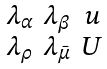Convert formula to latex. <formula><loc_0><loc_0><loc_500><loc_500>\begin{smallmatrix} \lambda _ { \alpha } & \lambda _ { \beta } & u \\ \lambda _ { \rho } & \lambda _ { \bar { \mu } } & U \end{smallmatrix}</formula> 